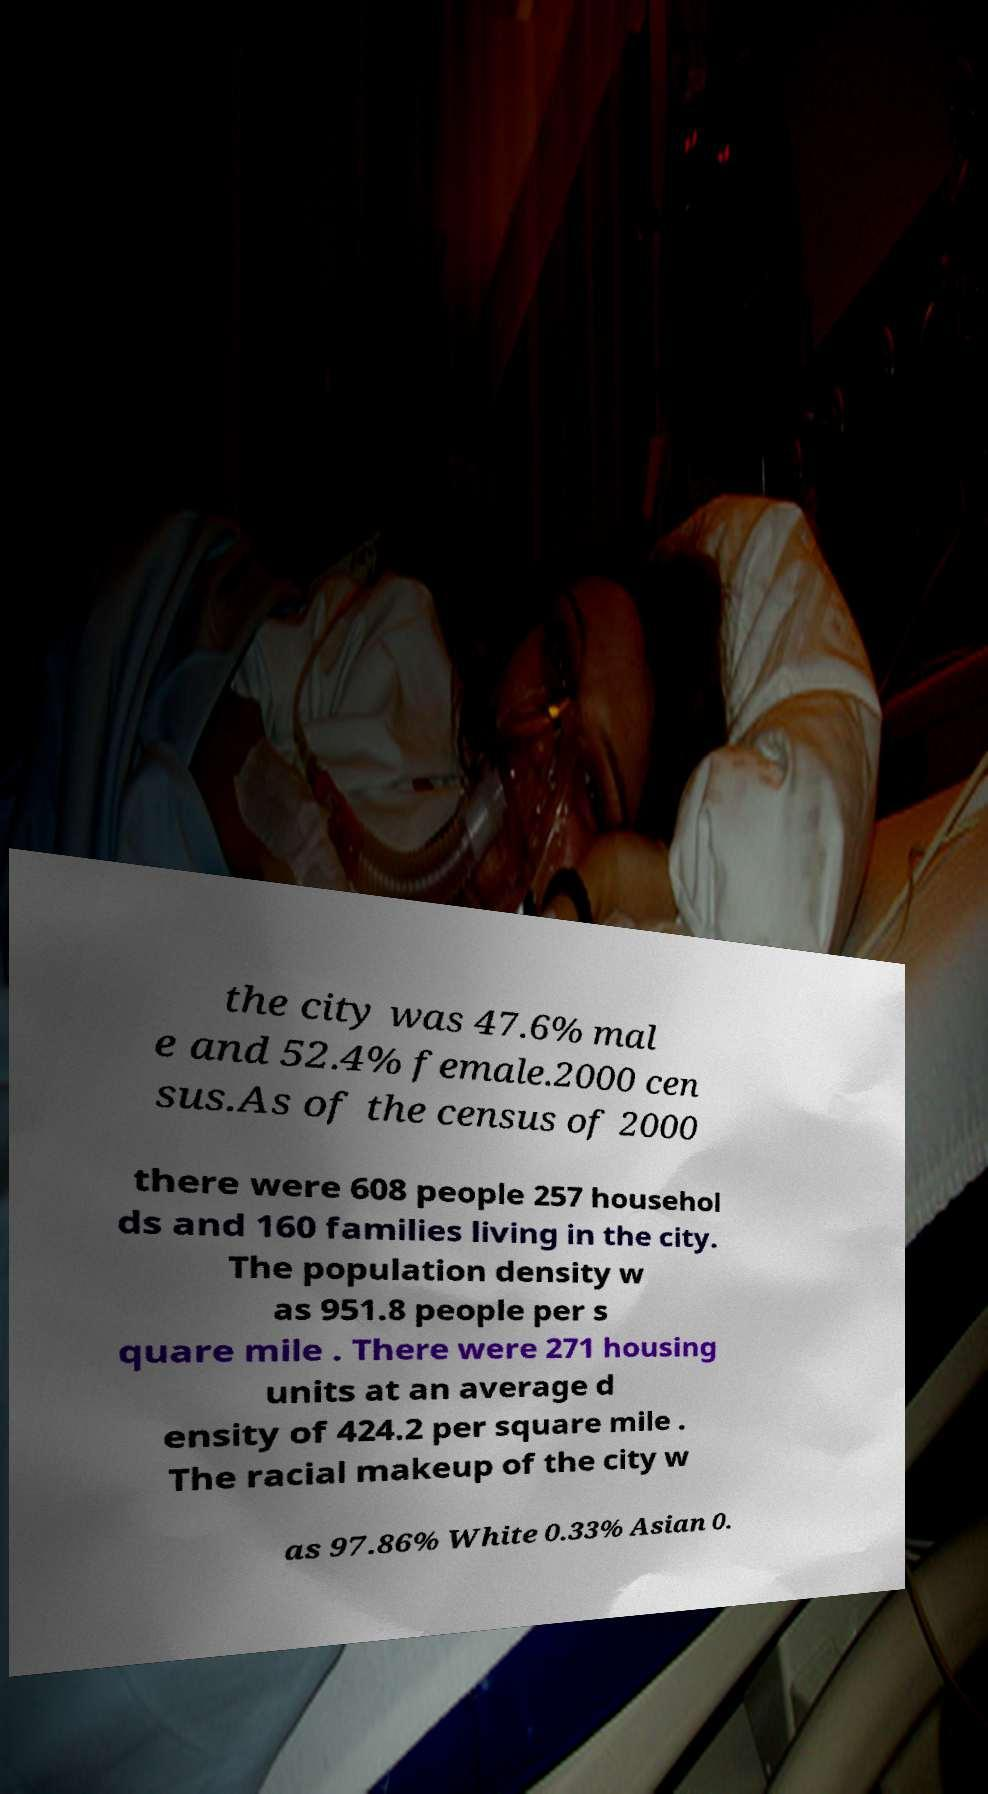Could you extract and type out the text from this image? the city was 47.6% mal e and 52.4% female.2000 cen sus.As of the census of 2000 there were 608 people 257 househol ds and 160 families living in the city. The population density w as 951.8 people per s quare mile . There were 271 housing units at an average d ensity of 424.2 per square mile . The racial makeup of the city w as 97.86% White 0.33% Asian 0. 